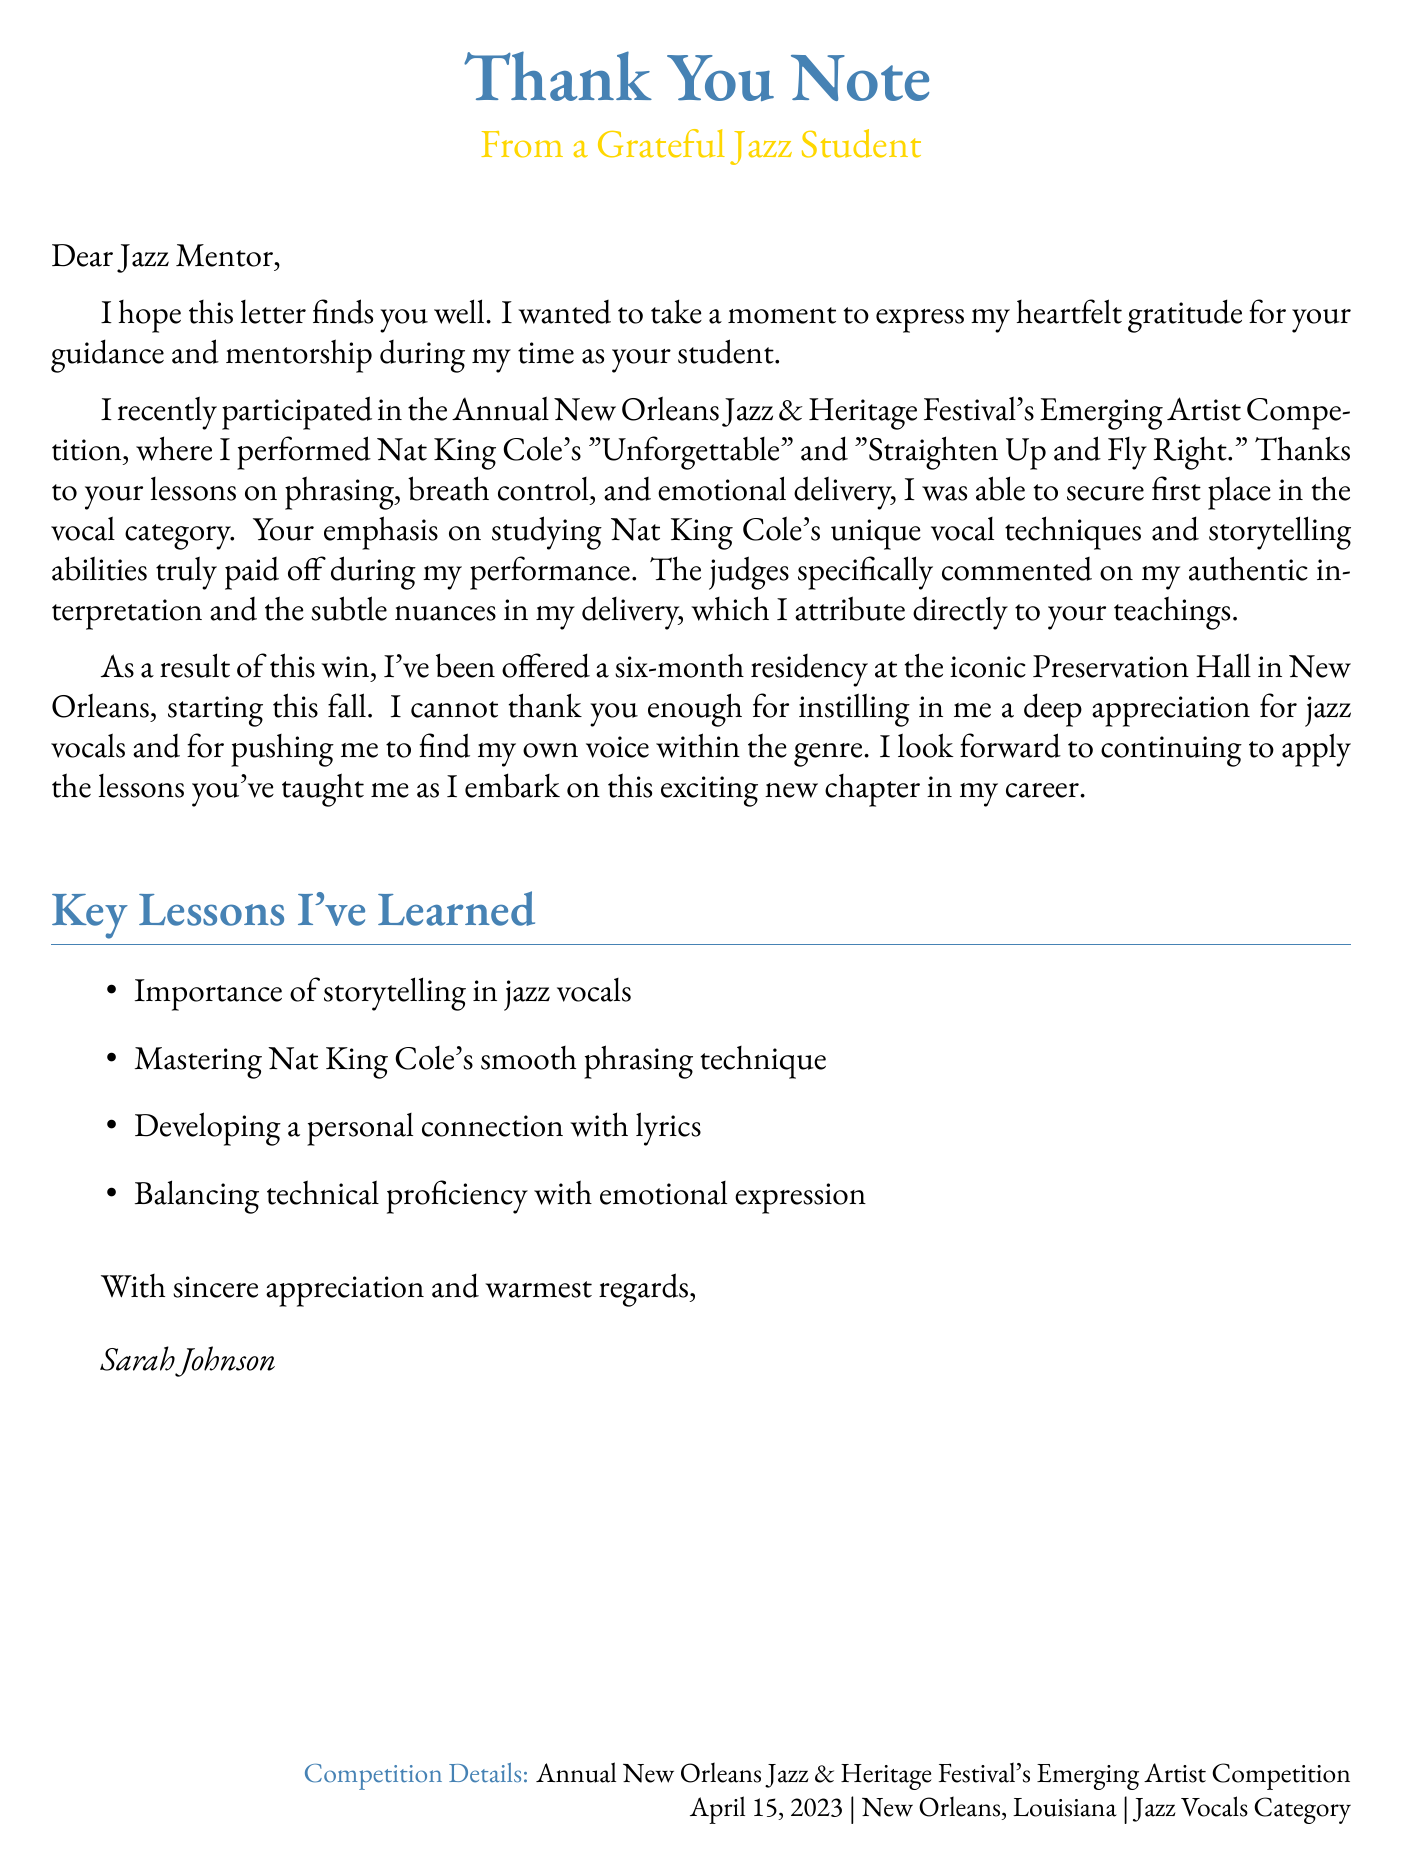What is the student’s name? The letter is signed by Sarah Johnson, indicating that she is the student.
Answer: Sarah Johnson What competition did the student participate in? The competition mentioned in the document is the Annual New Orleans Jazz & Heritage Festival's Emerging Artist Competition.
Answer: Annual New Orleans Jazz & Heritage Festival's Emerging Artist Competition What song by Nat King Cole did the student perform first? The letter mentions that the student performed "Unforgettable" first during the competition.
Answer: Unforgettable What was the student's achievement in the competition? The document states that the student secured first place in the vocal category of the competition.
Answer: First place What residency has the student been offered? The student mentions receiving a six-month residency at Preservation Hall in New Orleans.
Answer: Preservation Hall How long did the student study under the vocal coach? The document indicates that the student studied for three years.
Answer: 3 years What date was the competition held? The letter specifies that the competition took place on April 15, 2023.
Answer: April 15, 2023 What key lesson emphasized the importance of lyrics? The document highlights the lesson focused on developing a personal connection with lyrics.
Answer: Developing a personal connection with lyrics What type of vocal techniques did the mentor emphasize? The mentor emphasized studying Nat King Cole's unique vocal techniques throughout the lessons.
Answer: Vocal techniques 